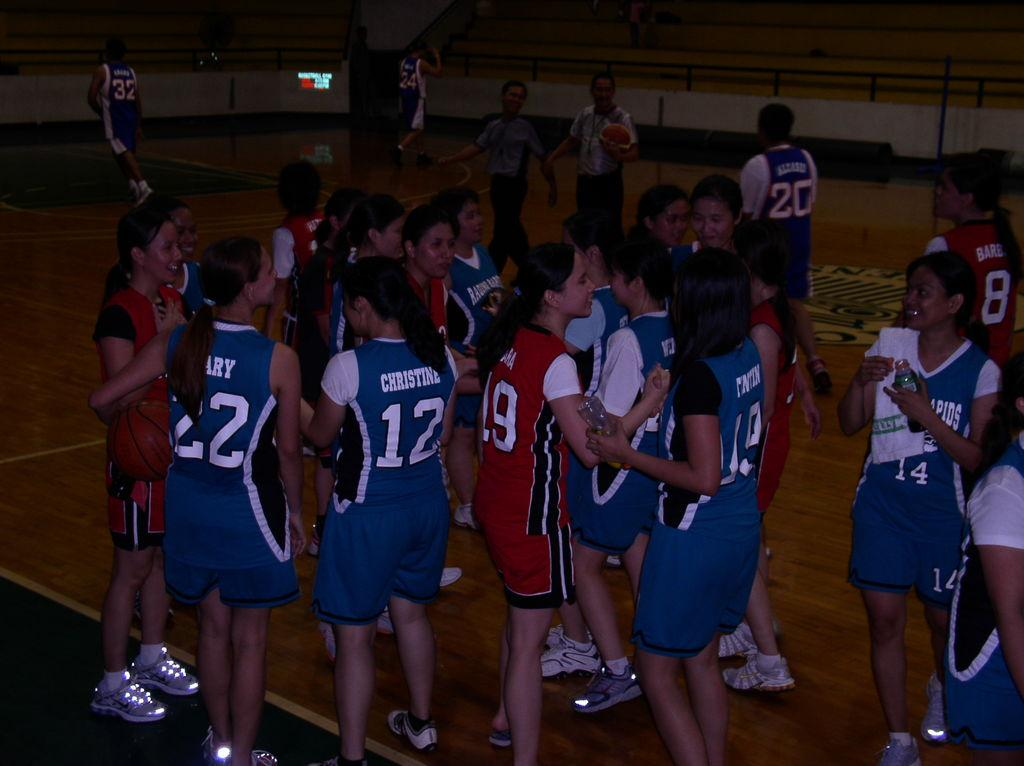Provide a one-sentence caption for the provided image. A player with the number 12 on stands with other players. 